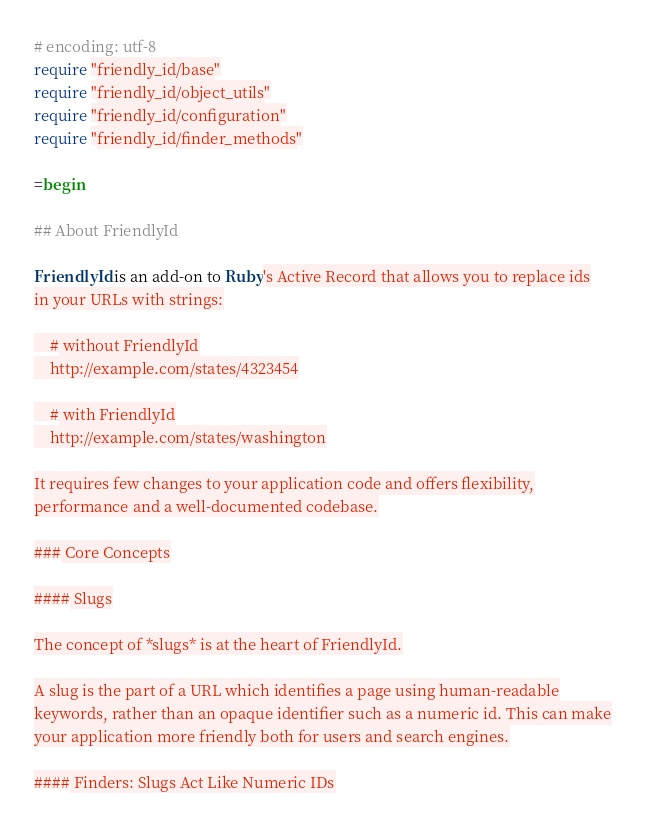Convert code to text. <code><loc_0><loc_0><loc_500><loc_500><_Ruby_># encoding: utf-8
require "friendly_id/base"
require "friendly_id/object_utils"
require "friendly_id/configuration"
require "friendly_id/finder_methods"

=begin

## About FriendlyId

FriendlyId is an add-on to Ruby's Active Record that allows you to replace ids
in your URLs with strings:

    # without FriendlyId
    http://example.com/states/4323454

    # with FriendlyId
    http://example.com/states/washington

It requires few changes to your application code and offers flexibility,
performance and a well-documented codebase.

### Core Concepts

#### Slugs

The concept of *slugs* is at the heart of FriendlyId.

A slug is the part of a URL which identifies a page using human-readable
keywords, rather than an opaque identifier such as a numeric id. This can make
your application more friendly both for users and search engines.

#### Finders: Slugs Act Like Numeric IDs
</code> 